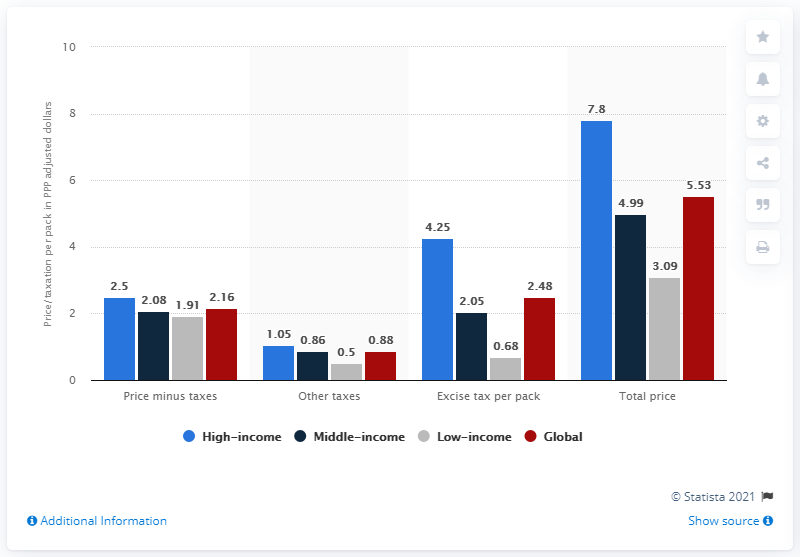Mention a couple of crucial points in this snapshot. The highest blue bar has a value of 7.8. The sum of all the bars in the other takes is 3.29... 